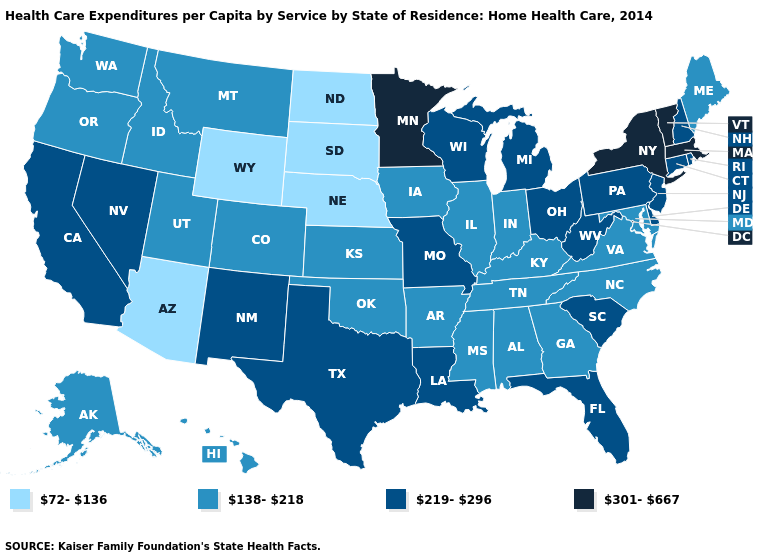Is the legend a continuous bar?
Short answer required. No. What is the value of Florida?
Quick response, please. 219-296. Does the map have missing data?
Keep it brief. No. Which states have the highest value in the USA?
Write a very short answer. Massachusetts, Minnesota, New York, Vermont. Name the states that have a value in the range 301-667?
Concise answer only. Massachusetts, Minnesota, New York, Vermont. What is the lowest value in states that border Arizona?
Be succinct. 138-218. What is the value of Maryland?
Be succinct. 138-218. What is the highest value in the South ?
Answer briefly. 219-296. Which states hav the highest value in the Northeast?
Be succinct. Massachusetts, New York, Vermont. What is the value of Mississippi?
Concise answer only. 138-218. What is the value of Massachusetts?
Give a very brief answer. 301-667. What is the highest value in the USA?
Be succinct. 301-667. Which states hav the highest value in the West?
Quick response, please. California, Nevada, New Mexico. Name the states that have a value in the range 72-136?
Give a very brief answer. Arizona, Nebraska, North Dakota, South Dakota, Wyoming. How many symbols are there in the legend?
Quick response, please. 4. 